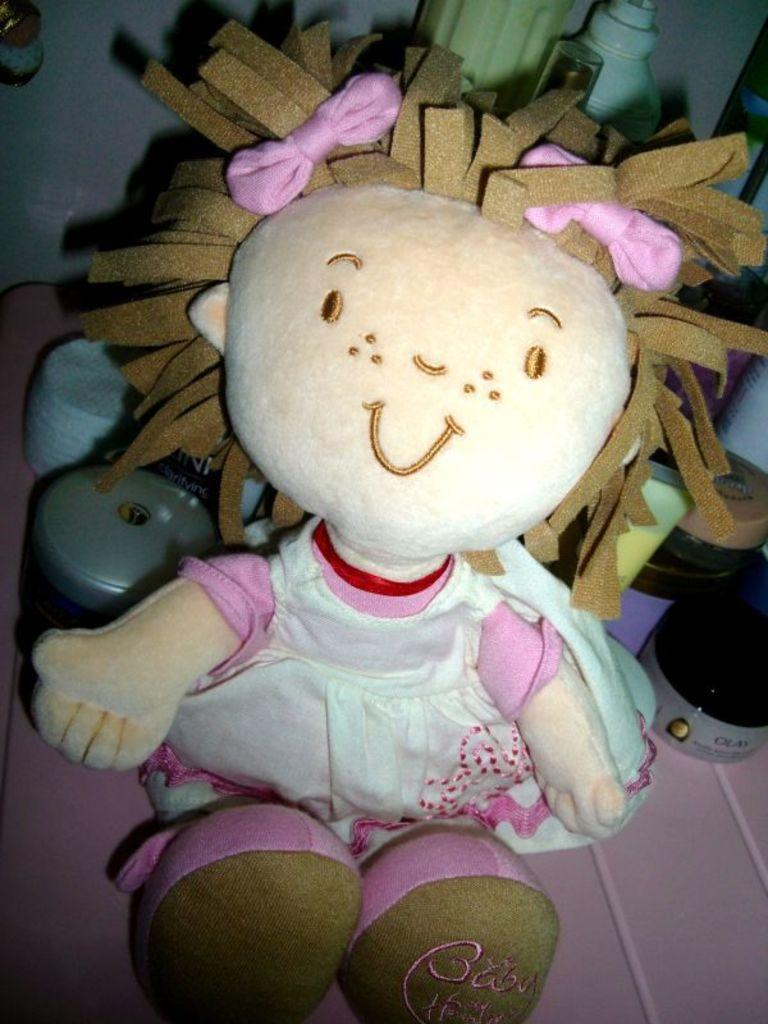What is the main subject in the center of the image? There is a doll in the center of the image. What else can be seen in the background of the image? There are bottles in the background of the image. What type of tooth is visible in the image? There is no tooth present in the image. 